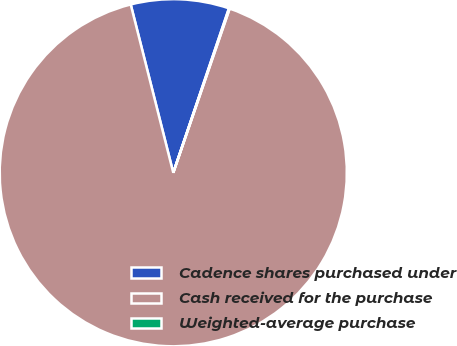<chart> <loc_0><loc_0><loc_500><loc_500><pie_chart><fcel>Cadence shares purchased under<fcel>Cash received for the purchase<fcel>Weighted-average purchase<nl><fcel>9.14%<fcel>90.79%<fcel>0.07%<nl></chart> 